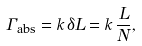Convert formula to latex. <formula><loc_0><loc_0><loc_500><loc_500>\Gamma _ { \text {abs} } = k \, \delta L = k \, \frac { L } { N } ,</formula> 